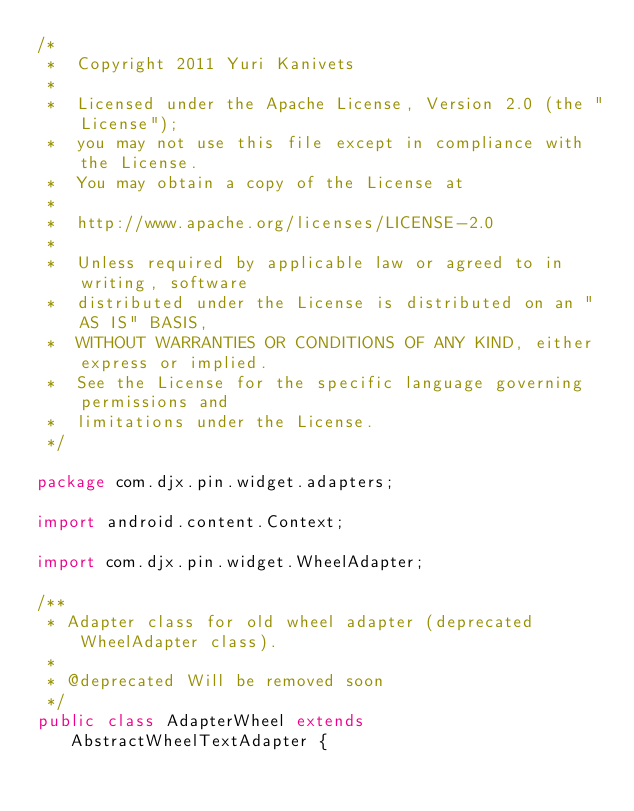Convert code to text. <code><loc_0><loc_0><loc_500><loc_500><_Java_>/*
 *  Copyright 2011 Yuri Kanivets
 *
 *  Licensed under the Apache License, Version 2.0 (the "License");
 *  you may not use this file except in compliance with the License.
 *  You may obtain a copy of the License at
 *
 *  http://www.apache.org/licenses/LICENSE-2.0
 *
 *  Unless required by applicable law or agreed to in writing, software
 *  distributed under the License is distributed on an "AS IS" BASIS,
 *  WITHOUT WARRANTIES OR CONDITIONS OF ANY KIND, either express or implied.
 *  See the License for the specific language governing permissions and
 *  limitations under the License.
 */

package com.djx.pin.widget.adapters;

import android.content.Context;

import com.djx.pin.widget.WheelAdapter;

/**
 * Adapter class for old wheel adapter (deprecated WheelAdapter class).
 * 
 * @deprecated Will be removed soon
 */
public class AdapterWheel extends AbstractWheelTextAdapter {
</code> 